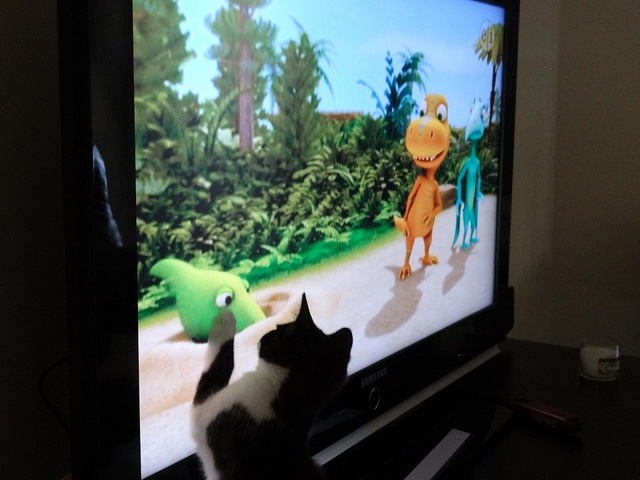Describe the objects in this image and their specific colors. I can see tv in black, lightblue, lightgray, and darkgreen tones, cat in black, gray, and darkgray tones, and cup in black and gray tones in this image. 